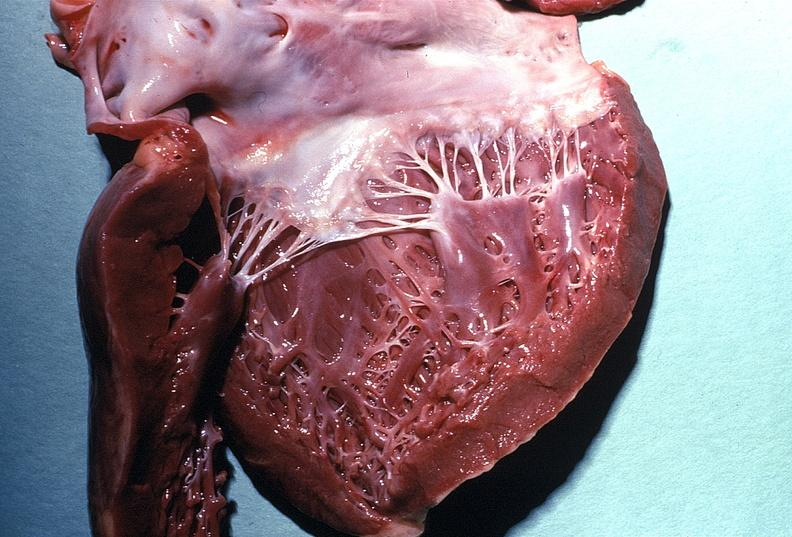where is this?
Answer the question using a single word or phrase. Heart 